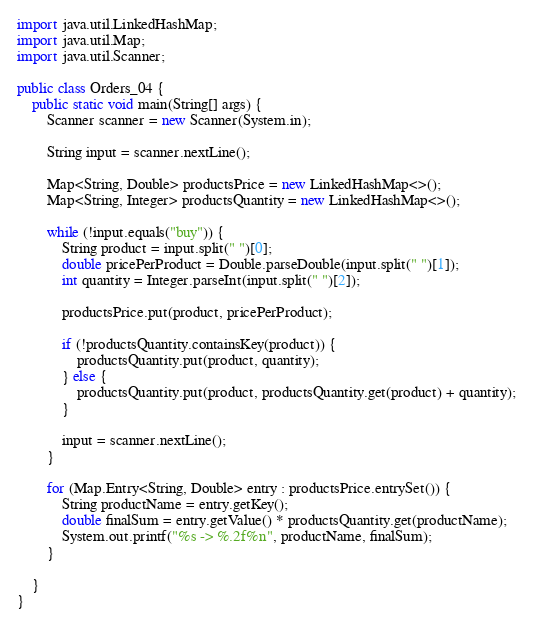Convert code to text. <code><loc_0><loc_0><loc_500><loc_500><_Java_>import java.util.LinkedHashMap;
import java.util.Map;
import java.util.Scanner;

public class Orders_04 {
    public static void main(String[] args) {
        Scanner scanner = new Scanner(System.in);

        String input = scanner.nextLine();

        Map<String, Double> productsPrice = new LinkedHashMap<>();
        Map<String, Integer> productsQuantity = new LinkedHashMap<>();

        while (!input.equals("buy")) {
            String product = input.split(" ")[0];
            double pricePerProduct = Double.parseDouble(input.split(" ")[1]);
            int quantity = Integer.parseInt(input.split(" ")[2]);

            productsPrice.put(product, pricePerProduct);

            if (!productsQuantity.containsKey(product)) {
                productsQuantity.put(product, quantity);
            } else {
                productsQuantity.put(product, productsQuantity.get(product) + quantity);
            }

            input = scanner.nextLine();
        }

        for (Map.Entry<String, Double> entry : productsPrice.entrySet()) {
            String productName = entry.getKey();
            double finalSum = entry.getValue() * productsQuantity.get(productName);
            System.out.printf("%s -> %.2f%n", productName, finalSum);
        }

    }
}
</code> 